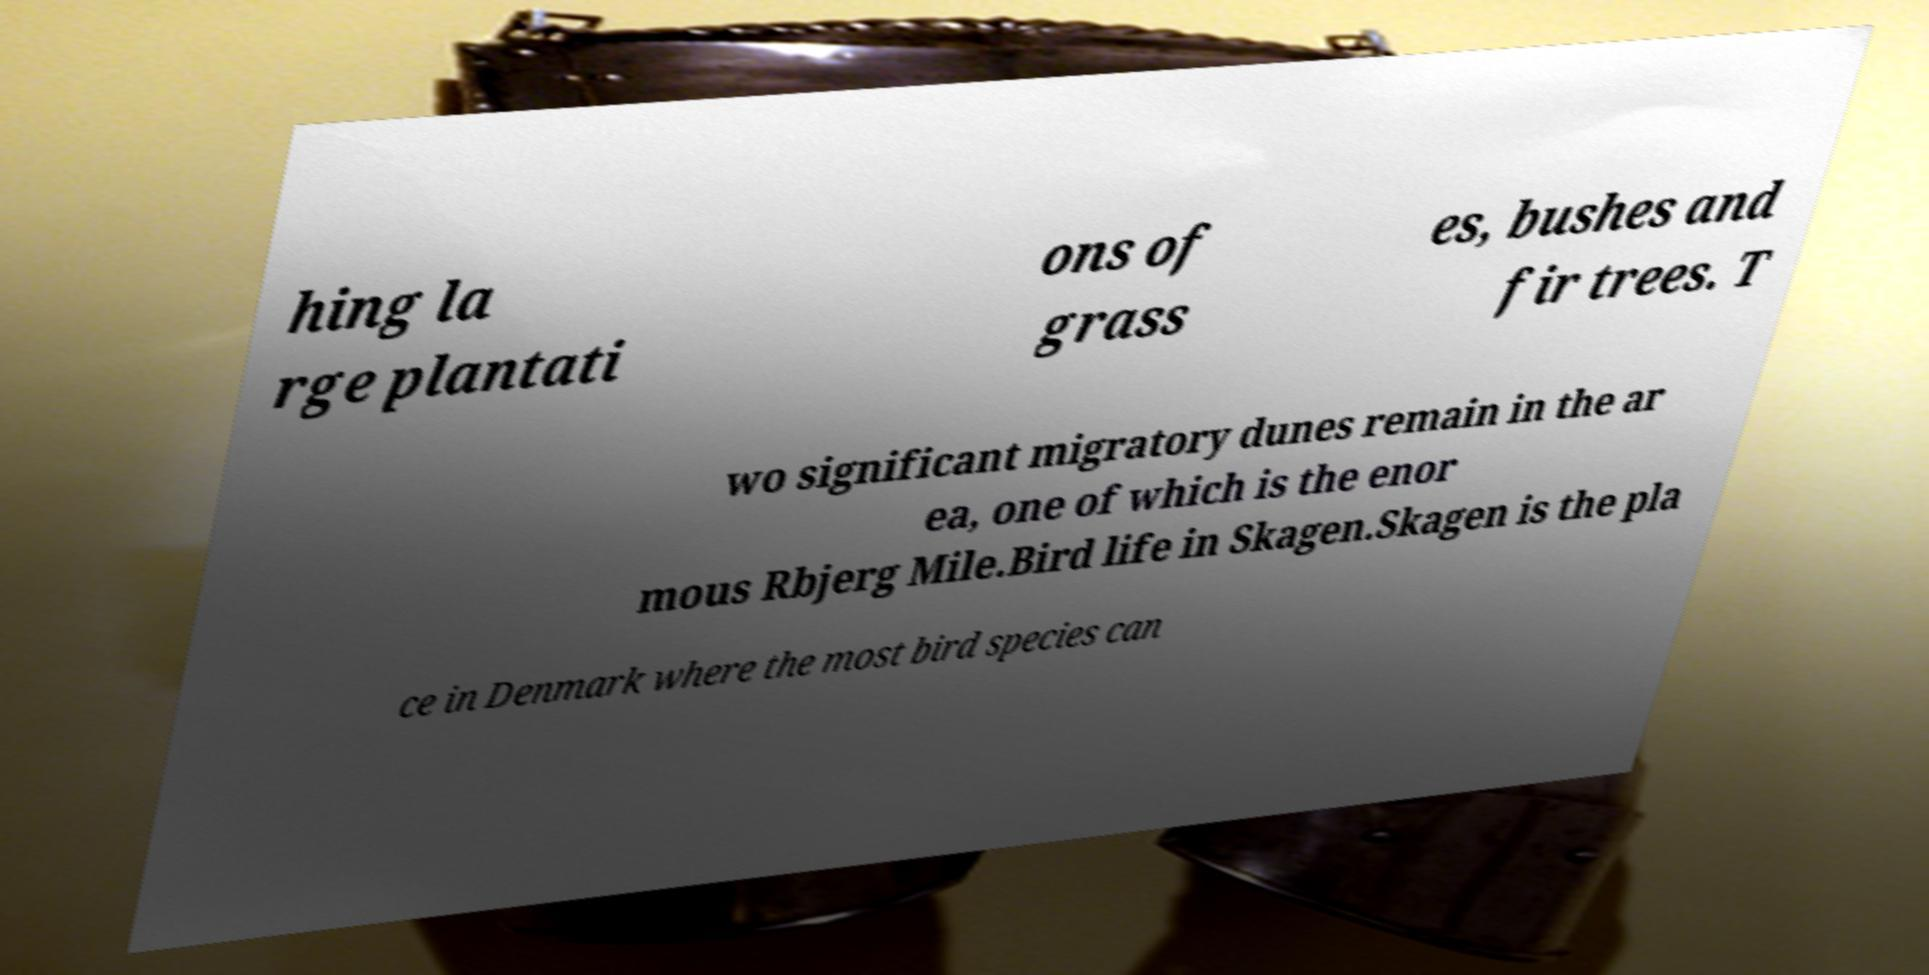There's text embedded in this image that I need extracted. Can you transcribe it verbatim? hing la rge plantati ons of grass es, bushes and fir trees. T wo significant migratory dunes remain in the ar ea, one of which is the enor mous Rbjerg Mile.Bird life in Skagen.Skagen is the pla ce in Denmark where the most bird species can 